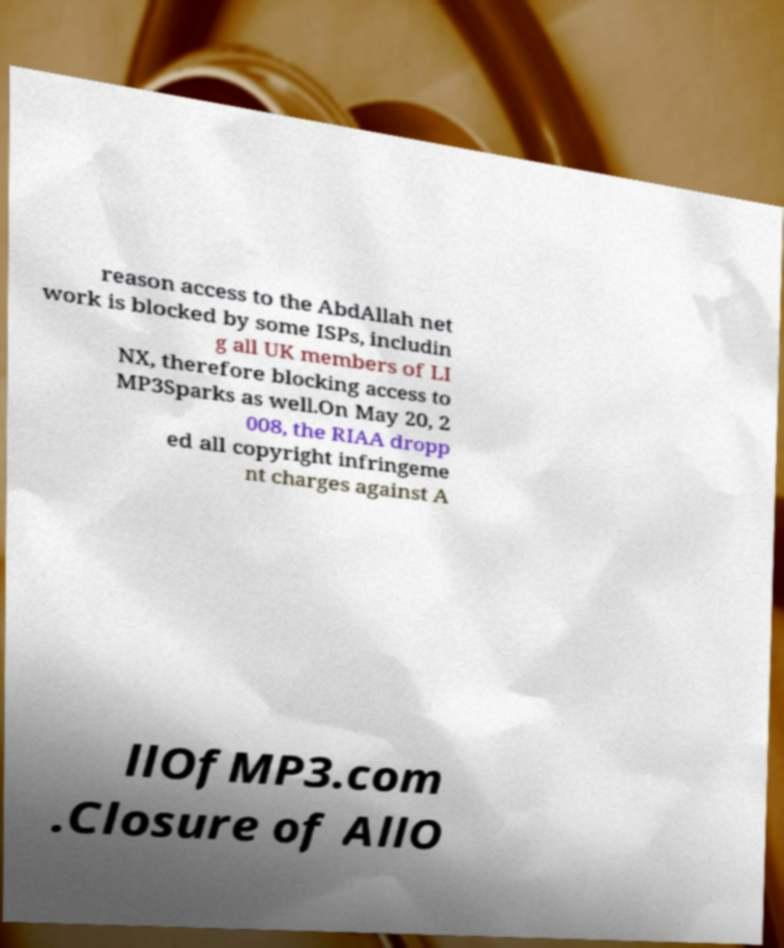There's text embedded in this image that I need extracted. Can you transcribe it verbatim? reason access to the AbdAllah net work is blocked by some ISPs, includin g all UK members of LI NX, therefore blocking access to MP3Sparks as well.On May 20, 2 008, the RIAA dropp ed all copyright infringeme nt charges against A llOfMP3.com .Closure of AllO 